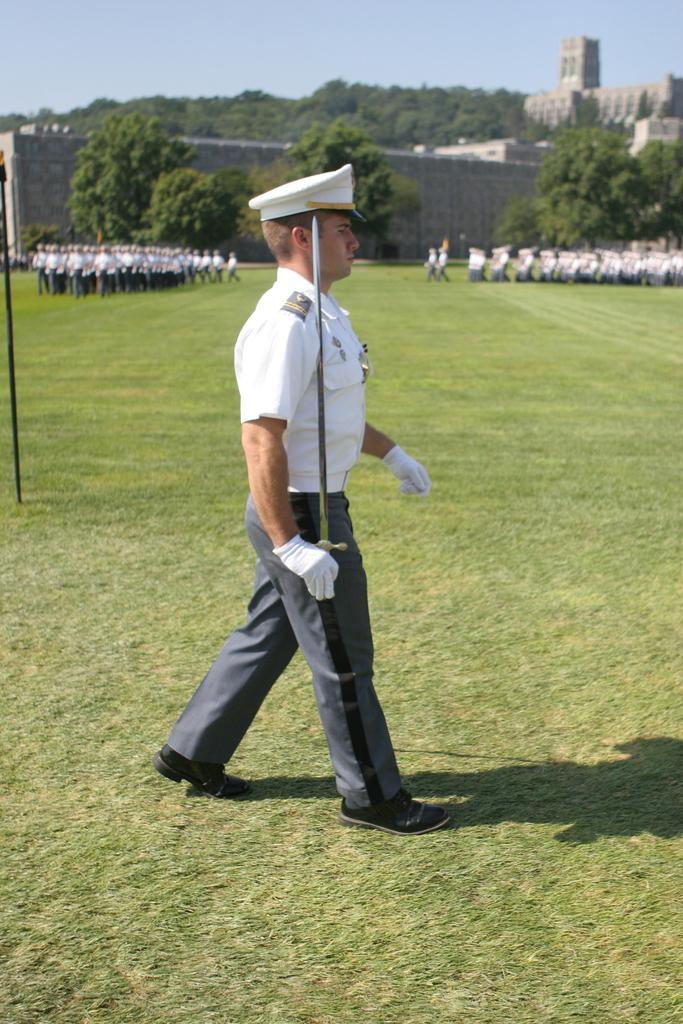What is the person in the image wearing? The person in the image is wearing a uniform. What is the person holding in the image? The person is holding a sword. Where is the person standing in the image? The person is standing on the grass. What is happening in the background of the image? There are people doing a parade and there are trees, buildings, and a pole in the background. What is the weight of the impulse that can be felt in the wilderness in the image? There is no mention of an impulse or wilderness in the image; it features a person in uniform holding a sword and standing on the grass with a parade and background elements in the distance. 